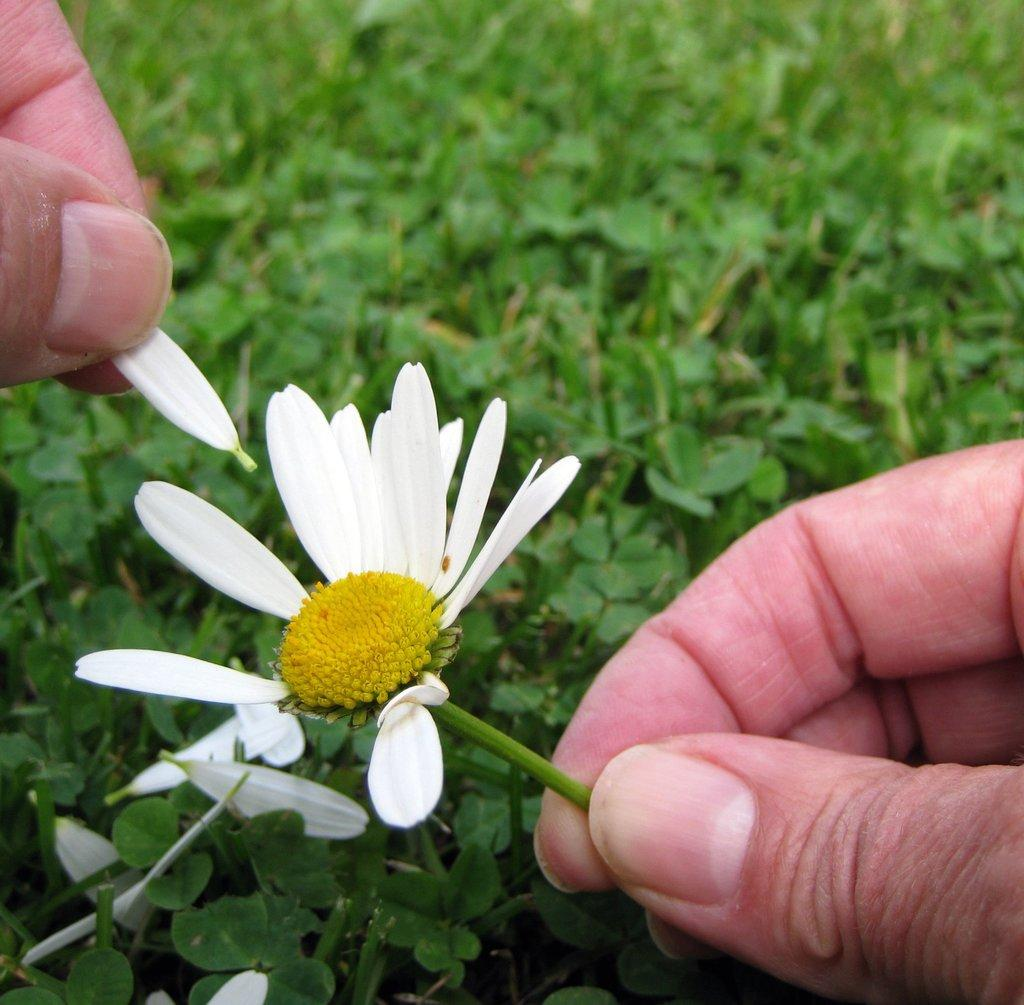What is the person holding in the image? The person's fingers are holding a flower in the image. Can you describe the flower? The flower has a petal. What can be seen in the background of the image? There are plants in the background of the image. What type of yarn is the person using to play with the flower in the image? There is no yarn or playing activity present in the image; the person is simply holding a flower. 